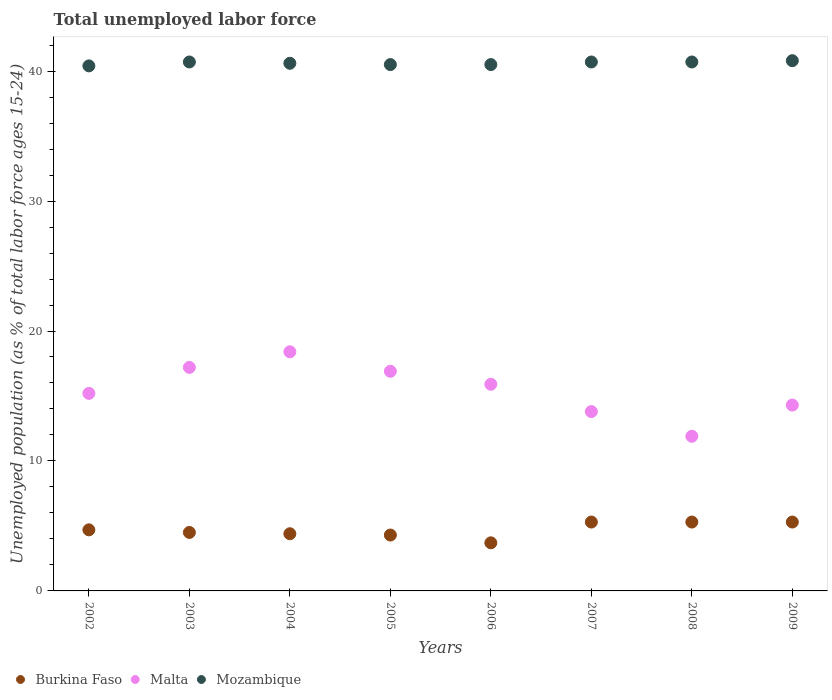Is the number of dotlines equal to the number of legend labels?
Your answer should be compact. Yes. What is the percentage of unemployed population in in Malta in 2005?
Make the answer very short. 16.9. Across all years, what is the maximum percentage of unemployed population in in Mozambique?
Offer a very short reply. 40.8. Across all years, what is the minimum percentage of unemployed population in in Malta?
Make the answer very short. 11.9. In which year was the percentage of unemployed population in in Mozambique maximum?
Your answer should be very brief. 2009. What is the total percentage of unemployed population in in Mozambique in the graph?
Your answer should be compact. 324.9. What is the difference between the percentage of unemployed population in in Burkina Faso in 2002 and that in 2003?
Provide a short and direct response. 0.2. What is the difference between the percentage of unemployed population in in Burkina Faso in 2005 and the percentage of unemployed population in in Mozambique in 2007?
Keep it short and to the point. -36.4. What is the average percentage of unemployed population in in Malta per year?
Provide a short and direct response. 15.45. In the year 2004, what is the difference between the percentage of unemployed population in in Mozambique and percentage of unemployed population in in Malta?
Provide a short and direct response. 22.2. In how many years, is the percentage of unemployed population in in Burkina Faso greater than 6 %?
Offer a very short reply. 0. What is the ratio of the percentage of unemployed population in in Mozambique in 2005 to that in 2009?
Provide a short and direct response. 0.99. Is the percentage of unemployed population in in Burkina Faso in 2005 less than that in 2006?
Ensure brevity in your answer.  No. Is the difference between the percentage of unemployed population in in Mozambique in 2003 and 2008 greater than the difference between the percentage of unemployed population in in Malta in 2003 and 2008?
Keep it short and to the point. No. What is the difference between the highest and the second highest percentage of unemployed population in in Mozambique?
Your response must be concise. 0.1. What is the difference between the highest and the lowest percentage of unemployed population in in Mozambique?
Your answer should be very brief. 0.4. Is the sum of the percentage of unemployed population in in Burkina Faso in 2005 and 2006 greater than the maximum percentage of unemployed population in in Malta across all years?
Ensure brevity in your answer.  No. Is it the case that in every year, the sum of the percentage of unemployed population in in Mozambique and percentage of unemployed population in in Burkina Faso  is greater than the percentage of unemployed population in in Malta?
Make the answer very short. Yes. What is the difference between two consecutive major ticks on the Y-axis?
Ensure brevity in your answer.  10. Are the values on the major ticks of Y-axis written in scientific E-notation?
Keep it short and to the point. No. Does the graph contain any zero values?
Give a very brief answer. No. Does the graph contain grids?
Offer a terse response. No. How many legend labels are there?
Offer a terse response. 3. What is the title of the graph?
Provide a succinct answer. Total unemployed labor force. Does "Fiji" appear as one of the legend labels in the graph?
Your answer should be very brief. No. What is the label or title of the Y-axis?
Provide a short and direct response. Unemployed population (as % of total labor force ages 15-24). What is the Unemployed population (as % of total labor force ages 15-24) in Burkina Faso in 2002?
Your response must be concise. 4.7. What is the Unemployed population (as % of total labor force ages 15-24) in Malta in 2002?
Your answer should be very brief. 15.2. What is the Unemployed population (as % of total labor force ages 15-24) of Mozambique in 2002?
Your answer should be compact. 40.4. What is the Unemployed population (as % of total labor force ages 15-24) in Malta in 2003?
Make the answer very short. 17.2. What is the Unemployed population (as % of total labor force ages 15-24) in Mozambique in 2003?
Provide a short and direct response. 40.7. What is the Unemployed population (as % of total labor force ages 15-24) of Burkina Faso in 2004?
Your response must be concise. 4.4. What is the Unemployed population (as % of total labor force ages 15-24) in Malta in 2004?
Offer a very short reply. 18.4. What is the Unemployed population (as % of total labor force ages 15-24) in Mozambique in 2004?
Keep it short and to the point. 40.6. What is the Unemployed population (as % of total labor force ages 15-24) of Burkina Faso in 2005?
Make the answer very short. 4.3. What is the Unemployed population (as % of total labor force ages 15-24) in Malta in 2005?
Provide a short and direct response. 16.9. What is the Unemployed population (as % of total labor force ages 15-24) in Mozambique in 2005?
Offer a terse response. 40.5. What is the Unemployed population (as % of total labor force ages 15-24) in Burkina Faso in 2006?
Provide a short and direct response. 3.7. What is the Unemployed population (as % of total labor force ages 15-24) of Malta in 2006?
Your answer should be very brief. 15.9. What is the Unemployed population (as % of total labor force ages 15-24) of Mozambique in 2006?
Your response must be concise. 40.5. What is the Unemployed population (as % of total labor force ages 15-24) of Burkina Faso in 2007?
Your answer should be very brief. 5.3. What is the Unemployed population (as % of total labor force ages 15-24) in Malta in 2007?
Offer a terse response. 13.8. What is the Unemployed population (as % of total labor force ages 15-24) of Mozambique in 2007?
Provide a short and direct response. 40.7. What is the Unemployed population (as % of total labor force ages 15-24) of Burkina Faso in 2008?
Your response must be concise. 5.3. What is the Unemployed population (as % of total labor force ages 15-24) of Malta in 2008?
Provide a short and direct response. 11.9. What is the Unemployed population (as % of total labor force ages 15-24) in Mozambique in 2008?
Your answer should be very brief. 40.7. What is the Unemployed population (as % of total labor force ages 15-24) of Burkina Faso in 2009?
Offer a terse response. 5.3. What is the Unemployed population (as % of total labor force ages 15-24) of Malta in 2009?
Make the answer very short. 14.3. What is the Unemployed population (as % of total labor force ages 15-24) in Mozambique in 2009?
Provide a short and direct response. 40.8. Across all years, what is the maximum Unemployed population (as % of total labor force ages 15-24) in Burkina Faso?
Your answer should be very brief. 5.3. Across all years, what is the maximum Unemployed population (as % of total labor force ages 15-24) in Malta?
Your response must be concise. 18.4. Across all years, what is the maximum Unemployed population (as % of total labor force ages 15-24) of Mozambique?
Make the answer very short. 40.8. Across all years, what is the minimum Unemployed population (as % of total labor force ages 15-24) of Burkina Faso?
Your answer should be very brief. 3.7. Across all years, what is the minimum Unemployed population (as % of total labor force ages 15-24) of Malta?
Your answer should be compact. 11.9. Across all years, what is the minimum Unemployed population (as % of total labor force ages 15-24) in Mozambique?
Your answer should be compact. 40.4. What is the total Unemployed population (as % of total labor force ages 15-24) in Burkina Faso in the graph?
Ensure brevity in your answer.  37.5. What is the total Unemployed population (as % of total labor force ages 15-24) in Malta in the graph?
Your answer should be very brief. 123.6. What is the total Unemployed population (as % of total labor force ages 15-24) of Mozambique in the graph?
Your answer should be very brief. 324.9. What is the difference between the Unemployed population (as % of total labor force ages 15-24) in Burkina Faso in 2002 and that in 2003?
Provide a short and direct response. 0.2. What is the difference between the Unemployed population (as % of total labor force ages 15-24) in Mozambique in 2002 and that in 2003?
Offer a very short reply. -0.3. What is the difference between the Unemployed population (as % of total labor force ages 15-24) of Burkina Faso in 2002 and that in 2004?
Offer a terse response. 0.3. What is the difference between the Unemployed population (as % of total labor force ages 15-24) of Malta in 2002 and that in 2004?
Make the answer very short. -3.2. What is the difference between the Unemployed population (as % of total labor force ages 15-24) of Burkina Faso in 2002 and that in 2005?
Your response must be concise. 0.4. What is the difference between the Unemployed population (as % of total labor force ages 15-24) of Malta in 2002 and that in 2005?
Make the answer very short. -1.7. What is the difference between the Unemployed population (as % of total labor force ages 15-24) of Mozambique in 2002 and that in 2005?
Give a very brief answer. -0.1. What is the difference between the Unemployed population (as % of total labor force ages 15-24) in Malta in 2002 and that in 2006?
Make the answer very short. -0.7. What is the difference between the Unemployed population (as % of total labor force ages 15-24) in Mozambique in 2002 and that in 2006?
Offer a terse response. -0.1. What is the difference between the Unemployed population (as % of total labor force ages 15-24) of Burkina Faso in 2002 and that in 2007?
Give a very brief answer. -0.6. What is the difference between the Unemployed population (as % of total labor force ages 15-24) of Mozambique in 2002 and that in 2007?
Offer a very short reply. -0.3. What is the difference between the Unemployed population (as % of total labor force ages 15-24) of Burkina Faso in 2002 and that in 2008?
Your answer should be very brief. -0.6. What is the difference between the Unemployed population (as % of total labor force ages 15-24) in Mozambique in 2002 and that in 2008?
Provide a short and direct response. -0.3. What is the difference between the Unemployed population (as % of total labor force ages 15-24) of Burkina Faso in 2002 and that in 2009?
Provide a succinct answer. -0.6. What is the difference between the Unemployed population (as % of total labor force ages 15-24) in Malta in 2002 and that in 2009?
Make the answer very short. 0.9. What is the difference between the Unemployed population (as % of total labor force ages 15-24) of Burkina Faso in 2003 and that in 2004?
Your answer should be very brief. 0.1. What is the difference between the Unemployed population (as % of total labor force ages 15-24) in Malta in 2003 and that in 2004?
Your answer should be compact. -1.2. What is the difference between the Unemployed population (as % of total labor force ages 15-24) of Burkina Faso in 2003 and that in 2005?
Your response must be concise. 0.2. What is the difference between the Unemployed population (as % of total labor force ages 15-24) in Malta in 2003 and that in 2005?
Provide a short and direct response. 0.3. What is the difference between the Unemployed population (as % of total labor force ages 15-24) in Mozambique in 2003 and that in 2006?
Provide a succinct answer. 0.2. What is the difference between the Unemployed population (as % of total labor force ages 15-24) in Mozambique in 2003 and that in 2007?
Provide a succinct answer. 0. What is the difference between the Unemployed population (as % of total labor force ages 15-24) in Burkina Faso in 2003 and that in 2008?
Ensure brevity in your answer.  -0.8. What is the difference between the Unemployed population (as % of total labor force ages 15-24) in Malta in 2003 and that in 2008?
Your answer should be very brief. 5.3. What is the difference between the Unemployed population (as % of total labor force ages 15-24) in Malta in 2003 and that in 2009?
Provide a short and direct response. 2.9. What is the difference between the Unemployed population (as % of total labor force ages 15-24) of Mozambique in 2003 and that in 2009?
Make the answer very short. -0.1. What is the difference between the Unemployed population (as % of total labor force ages 15-24) of Burkina Faso in 2004 and that in 2005?
Your response must be concise. 0.1. What is the difference between the Unemployed population (as % of total labor force ages 15-24) of Burkina Faso in 2004 and that in 2006?
Your answer should be very brief. 0.7. What is the difference between the Unemployed population (as % of total labor force ages 15-24) in Mozambique in 2004 and that in 2006?
Your answer should be very brief. 0.1. What is the difference between the Unemployed population (as % of total labor force ages 15-24) in Mozambique in 2004 and that in 2007?
Offer a very short reply. -0.1. What is the difference between the Unemployed population (as % of total labor force ages 15-24) in Mozambique in 2004 and that in 2009?
Your answer should be very brief. -0.2. What is the difference between the Unemployed population (as % of total labor force ages 15-24) of Malta in 2005 and that in 2007?
Give a very brief answer. 3.1. What is the difference between the Unemployed population (as % of total labor force ages 15-24) in Mozambique in 2005 and that in 2007?
Offer a terse response. -0.2. What is the difference between the Unemployed population (as % of total labor force ages 15-24) in Burkina Faso in 2005 and that in 2008?
Make the answer very short. -1. What is the difference between the Unemployed population (as % of total labor force ages 15-24) of Mozambique in 2005 and that in 2008?
Provide a short and direct response. -0.2. What is the difference between the Unemployed population (as % of total labor force ages 15-24) in Burkina Faso in 2005 and that in 2009?
Offer a terse response. -1. What is the difference between the Unemployed population (as % of total labor force ages 15-24) of Malta in 2005 and that in 2009?
Your response must be concise. 2.6. What is the difference between the Unemployed population (as % of total labor force ages 15-24) in Mozambique in 2005 and that in 2009?
Give a very brief answer. -0.3. What is the difference between the Unemployed population (as % of total labor force ages 15-24) in Burkina Faso in 2006 and that in 2007?
Provide a short and direct response. -1.6. What is the difference between the Unemployed population (as % of total labor force ages 15-24) of Malta in 2006 and that in 2007?
Offer a very short reply. 2.1. What is the difference between the Unemployed population (as % of total labor force ages 15-24) in Mozambique in 2006 and that in 2007?
Provide a succinct answer. -0.2. What is the difference between the Unemployed population (as % of total labor force ages 15-24) in Burkina Faso in 2006 and that in 2009?
Give a very brief answer. -1.6. What is the difference between the Unemployed population (as % of total labor force ages 15-24) in Burkina Faso in 2007 and that in 2008?
Provide a short and direct response. 0. What is the difference between the Unemployed population (as % of total labor force ages 15-24) of Malta in 2007 and that in 2008?
Offer a terse response. 1.9. What is the difference between the Unemployed population (as % of total labor force ages 15-24) of Mozambique in 2007 and that in 2008?
Your response must be concise. 0. What is the difference between the Unemployed population (as % of total labor force ages 15-24) in Burkina Faso in 2007 and that in 2009?
Give a very brief answer. 0. What is the difference between the Unemployed population (as % of total labor force ages 15-24) of Mozambique in 2007 and that in 2009?
Provide a succinct answer. -0.1. What is the difference between the Unemployed population (as % of total labor force ages 15-24) in Malta in 2008 and that in 2009?
Make the answer very short. -2.4. What is the difference between the Unemployed population (as % of total labor force ages 15-24) in Burkina Faso in 2002 and the Unemployed population (as % of total labor force ages 15-24) in Malta in 2003?
Offer a very short reply. -12.5. What is the difference between the Unemployed population (as % of total labor force ages 15-24) of Burkina Faso in 2002 and the Unemployed population (as % of total labor force ages 15-24) of Mozambique in 2003?
Offer a very short reply. -36. What is the difference between the Unemployed population (as % of total labor force ages 15-24) in Malta in 2002 and the Unemployed population (as % of total labor force ages 15-24) in Mozambique in 2003?
Give a very brief answer. -25.5. What is the difference between the Unemployed population (as % of total labor force ages 15-24) of Burkina Faso in 2002 and the Unemployed population (as % of total labor force ages 15-24) of Malta in 2004?
Offer a terse response. -13.7. What is the difference between the Unemployed population (as % of total labor force ages 15-24) in Burkina Faso in 2002 and the Unemployed population (as % of total labor force ages 15-24) in Mozambique in 2004?
Provide a short and direct response. -35.9. What is the difference between the Unemployed population (as % of total labor force ages 15-24) in Malta in 2002 and the Unemployed population (as % of total labor force ages 15-24) in Mozambique in 2004?
Keep it short and to the point. -25.4. What is the difference between the Unemployed population (as % of total labor force ages 15-24) of Burkina Faso in 2002 and the Unemployed population (as % of total labor force ages 15-24) of Malta in 2005?
Ensure brevity in your answer.  -12.2. What is the difference between the Unemployed population (as % of total labor force ages 15-24) in Burkina Faso in 2002 and the Unemployed population (as % of total labor force ages 15-24) in Mozambique in 2005?
Ensure brevity in your answer.  -35.8. What is the difference between the Unemployed population (as % of total labor force ages 15-24) in Malta in 2002 and the Unemployed population (as % of total labor force ages 15-24) in Mozambique in 2005?
Provide a succinct answer. -25.3. What is the difference between the Unemployed population (as % of total labor force ages 15-24) of Burkina Faso in 2002 and the Unemployed population (as % of total labor force ages 15-24) of Mozambique in 2006?
Give a very brief answer. -35.8. What is the difference between the Unemployed population (as % of total labor force ages 15-24) in Malta in 2002 and the Unemployed population (as % of total labor force ages 15-24) in Mozambique in 2006?
Give a very brief answer. -25.3. What is the difference between the Unemployed population (as % of total labor force ages 15-24) in Burkina Faso in 2002 and the Unemployed population (as % of total labor force ages 15-24) in Malta in 2007?
Your response must be concise. -9.1. What is the difference between the Unemployed population (as % of total labor force ages 15-24) in Burkina Faso in 2002 and the Unemployed population (as % of total labor force ages 15-24) in Mozambique in 2007?
Make the answer very short. -36. What is the difference between the Unemployed population (as % of total labor force ages 15-24) in Malta in 2002 and the Unemployed population (as % of total labor force ages 15-24) in Mozambique in 2007?
Provide a succinct answer. -25.5. What is the difference between the Unemployed population (as % of total labor force ages 15-24) in Burkina Faso in 2002 and the Unemployed population (as % of total labor force ages 15-24) in Mozambique in 2008?
Your answer should be compact. -36. What is the difference between the Unemployed population (as % of total labor force ages 15-24) in Malta in 2002 and the Unemployed population (as % of total labor force ages 15-24) in Mozambique in 2008?
Your response must be concise. -25.5. What is the difference between the Unemployed population (as % of total labor force ages 15-24) in Burkina Faso in 2002 and the Unemployed population (as % of total labor force ages 15-24) in Malta in 2009?
Offer a very short reply. -9.6. What is the difference between the Unemployed population (as % of total labor force ages 15-24) of Burkina Faso in 2002 and the Unemployed population (as % of total labor force ages 15-24) of Mozambique in 2009?
Your response must be concise. -36.1. What is the difference between the Unemployed population (as % of total labor force ages 15-24) of Malta in 2002 and the Unemployed population (as % of total labor force ages 15-24) of Mozambique in 2009?
Give a very brief answer. -25.6. What is the difference between the Unemployed population (as % of total labor force ages 15-24) of Burkina Faso in 2003 and the Unemployed population (as % of total labor force ages 15-24) of Malta in 2004?
Keep it short and to the point. -13.9. What is the difference between the Unemployed population (as % of total labor force ages 15-24) of Burkina Faso in 2003 and the Unemployed population (as % of total labor force ages 15-24) of Mozambique in 2004?
Your response must be concise. -36.1. What is the difference between the Unemployed population (as % of total labor force ages 15-24) of Malta in 2003 and the Unemployed population (as % of total labor force ages 15-24) of Mozambique in 2004?
Offer a terse response. -23.4. What is the difference between the Unemployed population (as % of total labor force ages 15-24) in Burkina Faso in 2003 and the Unemployed population (as % of total labor force ages 15-24) in Malta in 2005?
Provide a succinct answer. -12.4. What is the difference between the Unemployed population (as % of total labor force ages 15-24) in Burkina Faso in 2003 and the Unemployed population (as % of total labor force ages 15-24) in Mozambique in 2005?
Your answer should be compact. -36. What is the difference between the Unemployed population (as % of total labor force ages 15-24) of Malta in 2003 and the Unemployed population (as % of total labor force ages 15-24) of Mozambique in 2005?
Give a very brief answer. -23.3. What is the difference between the Unemployed population (as % of total labor force ages 15-24) in Burkina Faso in 2003 and the Unemployed population (as % of total labor force ages 15-24) in Malta in 2006?
Give a very brief answer. -11.4. What is the difference between the Unemployed population (as % of total labor force ages 15-24) in Burkina Faso in 2003 and the Unemployed population (as % of total labor force ages 15-24) in Mozambique in 2006?
Offer a terse response. -36. What is the difference between the Unemployed population (as % of total labor force ages 15-24) in Malta in 2003 and the Unemployed population (as % of total labor force ages 15-24) in Mozambique in 2006?
Your answer should be very brief. -23.3. What is the difference between the Unemployed population (as % of total labor force ages 15-24) of Burkina Faso in 2003 and the Unemployed population (as % of total labor force ages 15-24) of Malta in 2007?
Give a very brief answer. -9.3. What is the difference between the Unemployed population (as % of total labor force ages 15-24) in Burkina Faso in 2003 and the Unemployed population (as % of total labor force ages 15-24) in Mozambique in 2007?
Give a very brief answer. -36.2. What is the difference between the Unemployed population (as % of total labor force ages 15-24) of Malta in 2003 and the Unemployed population (as % of total labor force ages 15-24) of Mozambique in 2007?
Offer a terse response. -23.5. What is the difference between the Unemployed population (as % of total labor force ages 15-24) in Burkina Faso in 2003 and the Unemployed population (as % of total labor force ages 15-24) in Malta in 2008?
Provide a succinct answer. -7.4. What is the difference between the Unemployed population (as % of total labor force ages 15-24) in Burkina Faso in 2003 and the Unemployed population (as % of total labor force ages 15-24) in Mozambique in 2008?
Offer a terse response. -36.2. What is the difference between the Unemployed population (as % of total labor force ages 15-24) of Malta in 2003 and the Unemployed population (as % of total labor force ages 15-24) of Mozambique in 2008?
Give a very brief answer. -23.5. What is the difference between the Unemployed population (as % of total labor force ages 15-24) of Burkina Faso in 2003 and the Unemployed population (as % of total labor force ages 15-24) of Malta in 2009?
Offer a very short reply. -9.8. What is the difference between the Unemployed population (as % of total labor force ages 15-24) in Burkina Faso in 2003 and the Unemployed population (as % of total labor force ages 15-24) in Mozambique in 2009?
Your answer should be compact. -36.3. What is the difference between the Unemployed population (as % of total labor force ages 15-24) of Malta in 2003 and the Unemployed population (as % of total labor force ages 15-24) of Mozambique in 2009?
Provide a succinct answer. -23.6. What is the difference between the Unemployed population (as % of total labor force ages 15-24) of Burkina Faso in 2004 and the Unemployed population (as % of total labor force ages 15-24) of Malta in 2005?
Keep it short and to the point. -12.5. What is the difference between the Unemployed population (as % of total labor force ages 15-24) of Burkina Faso in 2004 and the Unemployed population (as % of total labor force ages 15-24) of Mozambique in 2005?
Your response must be concise. -36.1. What is the difference between the Unemployed population (as % of total labor force ages 15-24) of Malta in 2004 and the Unemployed population (as % of total labor force ages 15-24) of Mozambique in 2005?
Provide a succinct answer. -22.1. What is the difference between the Unemployed population (as % of total labor force ages 15-24) in Burkina Faso in 2004 and the Unemployed population (as % of total labor force ages 15-24) in Malta in 2006?
Offer a terse response. -11.5. What is the difference between the Unemployed population (as % of total labor force ages 15-24) in Burkina Faso in 2004 and the Unemployed population (as % of total labor force ages 15-24) in Mozambique in 2006?
Keep it short and to the point. -36.1. What is the difference between the Unemployed population (as % of total labor force ages 15-24) of Malta in 2004 and the Unemployed population (as % of total labor force ages 15-24) of Mozambique in 2006?
Your answer should be very brief. -22.1. What is the difference between the Unemployed population (as % of total labor force ages 15-24) in Burkina Faso in 2004 and the Unemployed population (as % of total labor force ages 15-24) in Mozambique in 2007?
Offer a terse response. -36.3. What is the difference between the Unemployed population (as % of total labor force ages 15-24) in Malta in 2004 and the Unemployed population (as % of total labor force ages 15-24) in Mozambique in 2007?
Offer a terse response. -22.3. What is the difference between the Unemployed population (as % of total labor force ages 15-24) of Burkina Faso in 2004 and the Unemployed population (as % of total labor force ages 15-24) of Malta in 2008?
Your response must be concise. -7.5. What is the difference between the Unemployed population (as % of total labor force ages 15-24) in Burkina Faso in 2004 and the Unemployed population (as % of total labor force ages 15-24) in Mozambique in 2008?
Offer a terse response. -36.3. What is the difference between the Unemployed population (as % of total labor force ages 15-24) of Malta in 2004 and the Unemployed population (as % of total labor force ages 15-24) of Mozambique in 2008?
Make the answer very short. -22.3. What is the difference between the Unemployed population (as % of total labor force ages 15-24) in Burkina Faso in 2004 and the Unemployed population (as % of total labor force ages 15-24) in Mozambique in 2009?
Give a very brief answer. -36.4. What is the difference between the Unemployed population (as % of total labor force ages 15-24) of Malta in 2004 and the Unemployed population (as % of total labor force ages 15-24) of Mozambique in 2009?
Give a very brief answer. -22.4. What is the difference between the Unemployed population (as % of total labor force ages 15-24) of Burkina Faso in 2005 and the Unemployed population (as % of total labor force ages 15-24) of Malta in 2006?
Offer a very short reply. -11.6. What is the difference between the Unemployed population (as % of total labor force ages 15-24) in Burkina Faso in 2005 and the Unemployed population (as % of total labor force ages 15-24) in Mozambique in 2006?
Your response must be concise. -36.2. What is the difference between the Unemployed population (as % of total labor force ages 15-24) in Malta in 2005 and the Unemployed population (as % of total labor force ages 15-24) in Mozambique in 2006?
Provide a succinct answer. -23.6. What is the difference between the Unemployed population (as % of total labor force ages 15-24) of Burkina Faso in 2005 and the Unemployed population (as % of total labor force ages 15-24) of Malta in 2007?
Make the answer very short. -9.5. What is the difference between the Unemployed population (as % of total labor force ages 15-24) in Burkina Faso in 2005 and the Unemployed population (as % of total labor force ages 15-24) in Mozambique in 2007?
Ensure brevity in your answer.  -36.4. What is the difference between the Unemployed population (as % of total labor force ages 15-24) in Malta in 2005 and the Unemployed population (as % of total labor force ages 15-24) in Mozambique in 2007?
Provide a succinct answer. -23.8. What is the difference between the Unemployed population (as % of total labor force ages 15-24) in Burkina Faso in 2005 and the Unemployed population (as % of total labor force ages 15-24) in Mozambique in 2008?
Make the answer very short. -36.4. What is the difference between the Unemployed population (as % of total labor force ages 15-24) in Malta in 2005 and the Unemployed population (as % of total labor force ages 15-24) in Mozambique in 2008?
Ensure brevity in your answer.  -23.8. What is the difference between the Unemployed population (as % of total labor force ages 15-24) in Burkina Faso in 2005 and the Unemployed population (as % of total labor force ages 15-24) in Mozambique in 2009?
Provide a short and direct response. -36.5. What is the difference between the Unemployed population (as % of total labor force ages 15-24) in Malta in 2005 and the Unemployed population (as % of total labor force ages 15-24) in Mozambique in 2009?
Give a very brief answer. -23.9. What is the difference between the Unemployed population (as % of total labor force ages 15-24) of Burkina Faso in 2006 and the Unemployed population (as % of total labor force ages 15-24) of Mozambique in 2007?
Keep it short and to the point. -37. What is the difference between the Unemployed population (as % of total labor force ages 15-24) in Malta in 2006 and the Unemployed population (as % of total labor force ages 15-24) in Mozambique in 2007?
Provide a succinct answer. -24.8. What is the difference between the Unemployed population (as % of total labor force ages 15-24) in Burkina Faso in 2006 and the Unemployed population (as % of total labor force ages 15-24) in Mozambique in 2008?
Give a very brief answer. -37. What is the difference between the Unemployed population (as % of total labor force ages 15-24) in Malta in 2006 and the Unemployed population (as % of total labor force ages 15-24) in Mozambique in 2008?
Provide a succinct answer. -24.8. What is the difference between the Unemployed population (as % of total labor force ages 15-24) of Burkina Faso in 2006 and the Unemployed population (as % of total labor force ages 15-24) of Malta in 2009?
Your answer should be very brief. -10.6. What is the difference between the Unemployed population (as % of total labor force ages 15-24) of Burkina Faso in 2006 and the Unemployed population (as % of total labor force ages 15-24) of Mozambique in 2009?
Provide a succinct answer. -37.1. What is the difference between the Unemployed population (as % of total labor force ages 15-24) of Malta in 2006 and the Unemployed population (as % of total labor force ages 15-24) of Mozambique in 2009?
Your answer should be very brief. -24.9. What is the difference between the Unemployed population (as % of total labor force ages 15-24) of Burkina Faso in 2007 and the Unemployed population (as % of total labor force ages 15-24) of Mozambique in 2008?
Your response must be concise. -35.4. What is the difference between the Unemployed population (as % of total labor force ages 15-24) of Malta in 2007 and the Unemployed population (as % of total labor force ages 15-24) of Mozambique in 2008?
Provide a short and direct response. -26.9. What is the difference between the Unemployed population (as % of total labor force ages 15-24) of Burkina Faso in 2007 and the Unemployed population (as % of total labor force ages 15-24) of Mozambique in 2009?
Offer a terse response. -35.5. What is the difference between the Unemployed population (as % of total labor force ages 15-24) of Malta in 2007 and the Unemployed population (as % of total labor force ages 15-24) of Mozambique in 2009?
Offer a terse response. -27. What is the difference between the Unemployed population (as % of total labor force ages 15-24) of Burkina Faso in 2008 and the Unemployed population (as % of total labor force ages 15-24) of Malta in 2009?
Ensure brevity in your answer.  -9. What is the difference between the Unemployed population (as % of total labor force ages 15-24) in Burkina Faso in 2008 and the Unemployed population (as % of total labor force ages 15-24) in Mozambique in 2009?
Offer a terse response. -35.5. What is the difference between the Unemployed population (as % of total labor force ages 15-24) in Malta in 2008 and the Unemployed population (as % of total labor force ages 15-24) in Mozambique in 2009?
Your response must be concise. -28.9. What is the average Unemployed population (as % of total labor force ages 15-24) of Burkina Faso per year?
Give a very brief answer. 4.69. What is the average Unemployed population (as % of total labor force ages 15-24) of Malta per year?
Provide a short and direct response. 15.45. What is the average Unemployed population (as % of total labor force ages 15-24) in Mozambique per year?
Keep it short and to the point. 40.61. In the year 2002, what is the difference between the Unemployed population (as % of total labor force ages 15-24) of Burkina Faso and Unemployed population (as % of total labor force ages 15-24) of Mozambique?
Your response must be concise. -35.7. In the year 2002, what is the difference between the Unemployed population (as % of total labor force ages 15-24) of Malta and Unemployed population (as % of total labor force ages 15-24) of Mozambique?
Offer a very short reply. -25.2. In the year 2003, what is the difference between the Unemployed population (as % of total labor force ages 15-24) in Burkina Faso and Unemployed population (as % of total labor force ages 15-24) in Mozambique?
Provide a succinct answer. -36.2. In the year 2003, what is the difference between the Unemployed population (as % of total labor force ages 15-24) in Malta and Unemployed population (as % of total labor force ages 15-24) in Mozambique?
Give a very brief answer. -23.5. In the year 2004, what is the difference between the Unemployed population (as % of total labor force ages 15-24) of Burkina Faso and Unemployed population (as % of total labor force ages 15-24) of Malta?
Make the answer very short. -14. In the year 2004, what is the difference between the Unemployed population (as % of total labor force ages 15-24) of Burkina Faso and Unemployed population (as % of total labor force ages 15-24) of Mozambique?
Make the answer very short. -36.2. In the year 2004, what is the difference between the Unemployed population (as % of total labor force ages 15-24) in Malta and Unemployed population (as % of total labor force ages 15-24) in Mozambique?
Give a very brief answer. -22.2. In the year 2005, what is the difference between the Unemployed population (as % of total labor force ages 15-24) of Burkina Faso and Unemployed population (as % of total labor force ages 15-24) of Malta?
Offer a very short reply. -12.6. In the year 2005, what is the difference between the Unemployed population (as % of total labor force ages 15-24) in Burkina Faso and Unemployed population (as % of total labor force ages 15-24) in Mozambique?
Offer a terse response. -36.2. In the year 2005, what is the difference between the Unemployed population (as % of total labor force ages 15-24) in Malta and Unemployed population (as % of total labor force ages 15-24) in Mozambique?
Make the answer very short. -23.6. In the year 2006, what is the difference between the Unemployed population (as % of total labor force ages 15-24) of Burkina Faso and Unemployed population (as % of total labor force ages 15-24) of Malta?
Provide a short and direct response. -12.2. In the year 2006, what is the difference between the Unemployed population (as % of total labor force ages 15-24) of Burkina Faso and Unemployed population (as % of total labor force ages 15-24) of Mozambique?
Your answer should be compact. -36.8. In the year 2006, what is the difference between the Unemployed population (as % of total labor force ages 15-24) of Malta and Unemployed population (as % of total labor force ages 15-24) of Mozambique?
Offer a very short reply. -24.6. In the year 2007, what is the difference between the Unemployed population (as % of total labor force ages 15-24) of Burkina Faso and Unemployed population (as % of total labor force ages 15-24) of Mozambique?
Provide a short and direct response. -35.4. In the year 2007, what is the difference between the Unemployed population (as % of total labor force ages 15-24) of Malta and Unemployed population (as % of total labor force ages 15-24) of Mozambique?
Give a very brief answer. -26.9. In the year 2008, what is the difference between the Unemployed population (as % of total labor force ages 15-24) in Burkina Faso and Unemployed population (as % of total labor force ages 15-24) in Mozambique?
Offer a terse response. -35.4. In the year 2008, what is the difference between the Unemployed population (as % of total labor force ages 15-24) in Malta and Unemployed population (as % of total labor force ages 15-24) in Mozambique?
Provide a succinct answer. -28.8. In the year 2009, what is the difference between the Unemployed population (as % of total labor force ages 15-24) of Burkina Faso and Unemployed population (as % of total labor force ages 15-24) of Malta?
Your response must be concise. -9. In the year 2009, what is the difference between the Unemployed population (as % of total labor force ages 15-24) in Burkina Faso and Unemployed population (as % of total labor force ages 15-24) in Mozambique?
Ensure brevity in your answer.  -35.5. In the year 2009, what is the difference between the Unemployed population (as % of total labor force ages 15-24) of Malta and Unemployed population (as % of total labor force ages 15-24) of Mozambique?
Give a very brief answer. -26.5. What is the ratio of the Unemployed population (as % of total labor force ages 15-24) of Burkina Faso in 2002 to that in 2003?
Offer a terse response. 1.04. What is the ratio of the Unemployed population (as % of total labor force ages 15-24) of Malta in 2002 to that in 2003?
Ensure brevity in your answer.  0.88. What is the ratio of the Unemployed population (as % of total labor force ages 15-24) in Burkina Faso in 2002 to that in 2004?
Make the answer very short. 1.07. What is the ratio of the Unemployed population (as % of total labor force ages 15-24) of Malta in 2002 to that in 2004?
Your response must be concise. 0.83. What is the ratio of the Unemployed population (as % of total labor force ages 15-24) in Burkina Faso in 2002 to that in 2005?
Your response must be concise. 1.09. What is the ratio of the Unemployed population (as % of total labor force ages 15-24) of Malta in 2002 to that in 2005?
Ensure brevity in your answer.  0.9. What is the ratio of the Unemployed population (as % of total labor force ages 15-24) of Burkina Faso in 2002 to that in 2006?
Provide a short and direct response. 1.27. What is the ratio of the Unemployed population (as % of total labor force ages 15-24) of Malta in 2002 to that in 2006?
Offer a very short reply. 0.96. What is the ratio of the Unemployed population (as % of total labor force ages 15-24) of Mozambique in 2002 to that in 2006?
Make the answer very short. 1. What is the ratio of the Unemployed population (as % of total labor force ages 15-24) of Burkina Faso in 2002 to that in 2007?
Ensure brevity in your answer.  0.89. What is the ratio of the Unemployed population (as % of total labor force ages 15-24) of Malta in 2002 to that in 2007?
Ensure brevity in your answer.  1.1. What is the ratio of the Unemployed population (as % of total labor force ages 15-24) in Burkina Faso in 2002 to that in 2008?
Your answer should be compact. 0.89. What is the ratio of the Unemployed population (as % of total labor force ages 15-24) of Malta in 2002 to that in 2008?
Your answer should be very brief. 1.28. What is the ratio of the Unemployed population (as % of total labor force ages 15-24) in Mozambique in 2002 to that in 2008?
Your answer should be compact. 0.99. What is the ratio of the Unemployed population (as % of total labor force ages 15-24) of Burkina Faso in 2002 to that in 2009?
Your response must be concise. 0.89. What is the ratio of the Unemployed population (as % of total labor force ages 15-24) in Malta in 2002 to that in 2009?
Your answer should be compact. 1.06. What is the ratio of the Unemployed population (as % of total labor force ages 15-24) in Mozambique in 2002 to that in 2009?
Your response must be concise. 0.99. What is the ratio of the Unemployed population (as % of total labor force ages 15-24) in Burkina Faso in 2003 to that in 2004?
Keep it short and to the point. 1.02. What is the ratio of the Unemployed population (as % of total labor force ages 15-24) in Malta in 2003 to that in 2004?
Offer a very short reply. 0.93. What is the ratio of the Unemployed population (as % of total labor force ages 15-24) of Mozambique in 2003 to that in 2004?
Offer a terse response. 1. What is the ratio of the Unemployed population (as % of total labor force ages 15-24) of Burkina Faso in 2003 to that in 2005?
Offer a very short reply. 1.05. What is the ratio of the Unemployed population (as % of total labor force ages 15-24) in Malta in 2003 to that in 2005?
Ensure brevity in your answer.  1.02. What is the ratio of the Unemployed population (as % of total labor force ages 15-24) of Burkina Faso in 2003 to that in 2006?
Give a very brief answer. 1.22. What is the ratio of the Unemployed population (as % of total labor force ages 15-24) in Malta in 2003 to that in 2006?
Give a very brief answer. 1.08. What is the ratio of the Unemployed population (as % of total labor force ages 15-24) of Mozambique in 2003 to that in 2006?
Give a very brief answer. 1. What is the ratio of the Unemployed population (as % of total labor force ages 15-24) of Burkina Faso in 2003 to that in 2007?
Give a very brief answer. 0.85. What is the ratio of the Unemployed population (as % of total labor force ages 15-24) in Malta in 2003 to that in 2007?
Make the answer very short. 1.25. What is the ratio of the Unemployed population (as % of total labor force ages 15-24) of Mozambique in 2003 to that in 2007?
Offer a very short reply. 1. What is the ratio of the Unemployed population (as % of total labor force ages 15-24) in Burkina Faso in 2003 to that in 2008?
Offer a terse response. 0.85. What is the ratio of the Unemployed population (as % of total labor force ages 15-24) in Malta in 2003 to that in 2008?
Your response must be concise. 1.45. What is the ratio of the Unemployed population (as % of total labor force ages 15-24) of Burkina Faso in 2003 to that in 2009?
Give a very brief answer. 0.85. What is the ratio of the Unemployed population (as % of total labor force ages 15-24) of Malta in 2003 to that in 2009?
Provide a short and direct response. 1.2. What is the ratio of the Unemployed population (as % of total labor force ages 15-24) in Burkina Faso in 2004 to that in 2005?
Your answer should be compact. 1.02. What is the ratio of the Unemployed population (as % of total labor force ages 15-24) of Malta in 2004 to that in 2005?
Give a very brief answer. 1.09. What is the ratio of the Unemployed population (as % of total labor force ages 15-24) of Mozambique in 2004 to that in 2005?
Your answer should be very brief. 1. What is the ratio of the Unemployed population (as % of total labor force ages 15-24) of Burkina Faso in 2004 to that in 2006?
Give a very brief answer. 1.19. What is the ratio of the Unemployed population (as % of total labor force ages 15-24) of Malta in 2004 to that in 2006?
Offer a very short reply. 1.16. What is the ratio of the Unemployed population (as % of total labor force ages 15-24) in Mozambique in 2004 to that in 2006?
Provide a succinct answer. 1. What is the ratio of the Unemployed population (as % of total labor force ages 15-24) in Burkina Faso in 2004 to that in 2007?
Ensure brevity in your answer.  0.83. What is the ratio of the Unemployed population (as % of total labor force ages 15-24) of Mozambique in 2004 to that in 2007?
Make the answer very short. 1. What is the ratio of the Unemployed population (as % of total labor force ages 15-24) of Burkina Faso in 2004 to that in 2008?
Your answer should be very brief. 0.83. What is the ratio of the Unemployed population (as % of total labor force ages 15-24) of Malta in 2004 to that in 2008?
Ensure brevity in your answer.  1.55. What is the ratio of the Unemployed population (as % of total labor force ages 15-24) of Mozambique in 2004 to that in 2008?
Keep it short and to the point. 1. What is the ratio of the Unemployed population (as % of total labor force ages 15-24) of Burkina Faso in 2004 to that in 2009?
Offer a terse response. 0.83. What is the ratio of the Unemployed population (as % of total labor force ages 15-24) in Malta in 2004 to that in 2009?
Your response must be concise. 1.29. What is the ratio of the Unemployed population (as % of total labor force ages 15-24) of Mozambique in 2004 to that in 2009?
Your answer should be very brief. 1. What is the ratio of the Unemployed population (as % of total labor force ages 15-24) of Burkina Faso in 2005 to that in 2006?
Provide a short and direct response. 1.16. What is the ratio of the Unemployed population (as % of total labor force ages 15-24) of Malta in 2005 to that in 2006?
Provide a succinct answer. 1.06. What is the ratio of the Unemployed population (as % of total labor force ages 15-24) of Mozambique in 2005 to that in 2006?
Make the answer very short. 1. What is the ratio of the Unemployed population (as % of total labor force ages 15-24) of Burkina Faso in 2005 to that in 2007?
Keep it short and to the point. 0.81. What is the ratio of the Unemployed population (as % of total labor force ages 15-24) in Malta in 2005 to that in 2007?
Keep it short and to the point. 1.22. What is the ratio of the Unemployed population (as % of total labor force ages 15-24) of Burkina Faso in 2005 to that in 2008?
Offer a terse response. 0.81. What is the ratio of the Unemployed population (as % of total labor force ages 15-24) of Malta in 2005 to that in 2008?
Offer a terse response. 1.42. What is the ratio of the Unemployed population (as % of total labor force ages 15-24) in Mozambique in 2005 to that in 2008?
Provide a succinct answer. 1. What is the ratio of the Unemployed population (as % of total labor force ages 15-24) of Burkina Faso in 2005 to that in 2009?
Make the answer very short. 0.81. What is the ratio of the Unemployed population (as % of total labor force ages 15-24) of Malta in 2005 to that in 2009?
Give a very brief answer. 1.18. What is the ratio of the Unemployed population (as % of total labor force ages 15-24) of Burkina Faso in 2006 to that in 2007?
Keep it short and to the point. 0.7. What is the ratio of the Unemployed population (as % of total labor force ages 15-24) of Malta in 2006 to that in 2007?
Ensure brevity in your answer.  1.15. What is the ratio of the Unemployed population (as % of total labor force ages 15-24) in Mozambique in 2006 to that in 2007?
Keep it short and to the point. 1. What is the ratio of the Unemployed population (as % of total labor force ages 15-24) in Burkina Faso in 2006 to that in 2008?
Your response must be concise. 0.7. What is the ratio of the Unemployed population (as % of total labor force ages 15-24) of Malta in 2006 to that in 2008?
Make the answer very short. 1.34. What is the ratio of the Unemployed population (as % of total labor force ages 15-24) in Burkina Faso in 2006 to that in 2009?
Provide a succinct answer. 0.7. What is the ratio of the Unemployed population (as % of total labor force ages 15-24) in Malta in 2006 to that in 2009?
Keep it short and to the point. 1.11. What is the ratio of the Unemployed population (as % of total labor force ages 15-24) in Malta in 2007 to that in 2008?
Keep it short and to the point. 1.16. What is the ratio of the Unemployed population (as % of total labor force ages 15-24) of Mozambique in 2007 to that in 2008?
Keep it short and to the point. 1. What is the ratio of the Unemployed population (as % of total labor force ages 15-24) of Burkina Faso in 2007 to that in 2009?
Give a very brief answer. 1. What is the ratio of the Unemployed population (as % of total labor force ages 15-24) of Mozambique in 2007 to that in 2009?
Offer a terse response. 1. What is the ratio of the Unemployed population (as % of total labor force ages 15-24) of Burkina Faso in 2008 to that in 2009?
Give a very brief answer. 1. What is the ratio of the Unemployed population (as % of total labor force ages 15-24) in Malta in 2008 to that in 2009?
Offer a very short reply. 0.83. What is the difference between the highest and the second highest Unemployed population (as % of total labor force ages 15-24) of Burkina Faso?
Your answer should be very brief. 0. What is the difference between the highest and the second highest Unemployed population (as % of total labor force ages 15-24) in Mozambique?
Give a very brief answer. 0.1. What is the difference between the highest and the lowest Unemployed population (as % of total labor force ages 15-24) in Burkina Faso?
Offer a terse response. 1.6. What is the difference between the highest and the lowest Unemployed population (as % of total labor force ages 15-24) in Mozambique?
Provide a short and direct response. 0.4. 